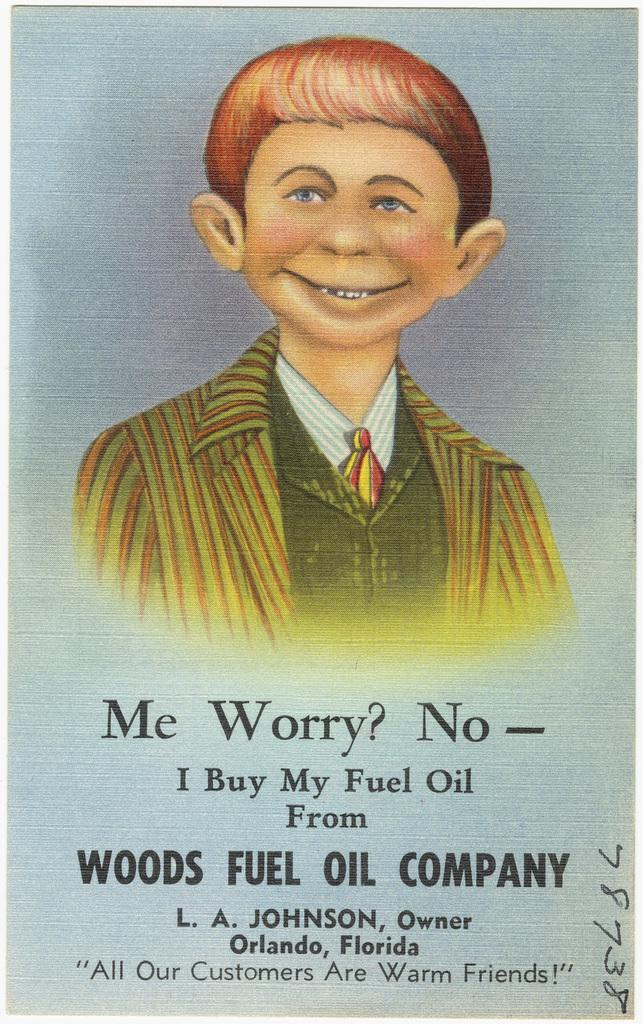What is there is an advertisement in the image, what is being advertised? The specific content of the advertisement cannot be determined from the provided facts. Can you describe the person's picture at the top of the image? The provided facts do not include any details about the person's picture, so it cannot be described. What type of information is conveyed through the text at the bottom of the image? The provided facts do not include any details about the text, so the type of information cannot be determined. What type of hose is being used to water the plants on the farm in the image? There is no hose or farm present in the image; it contains an advertisement with a person's picture and text. 